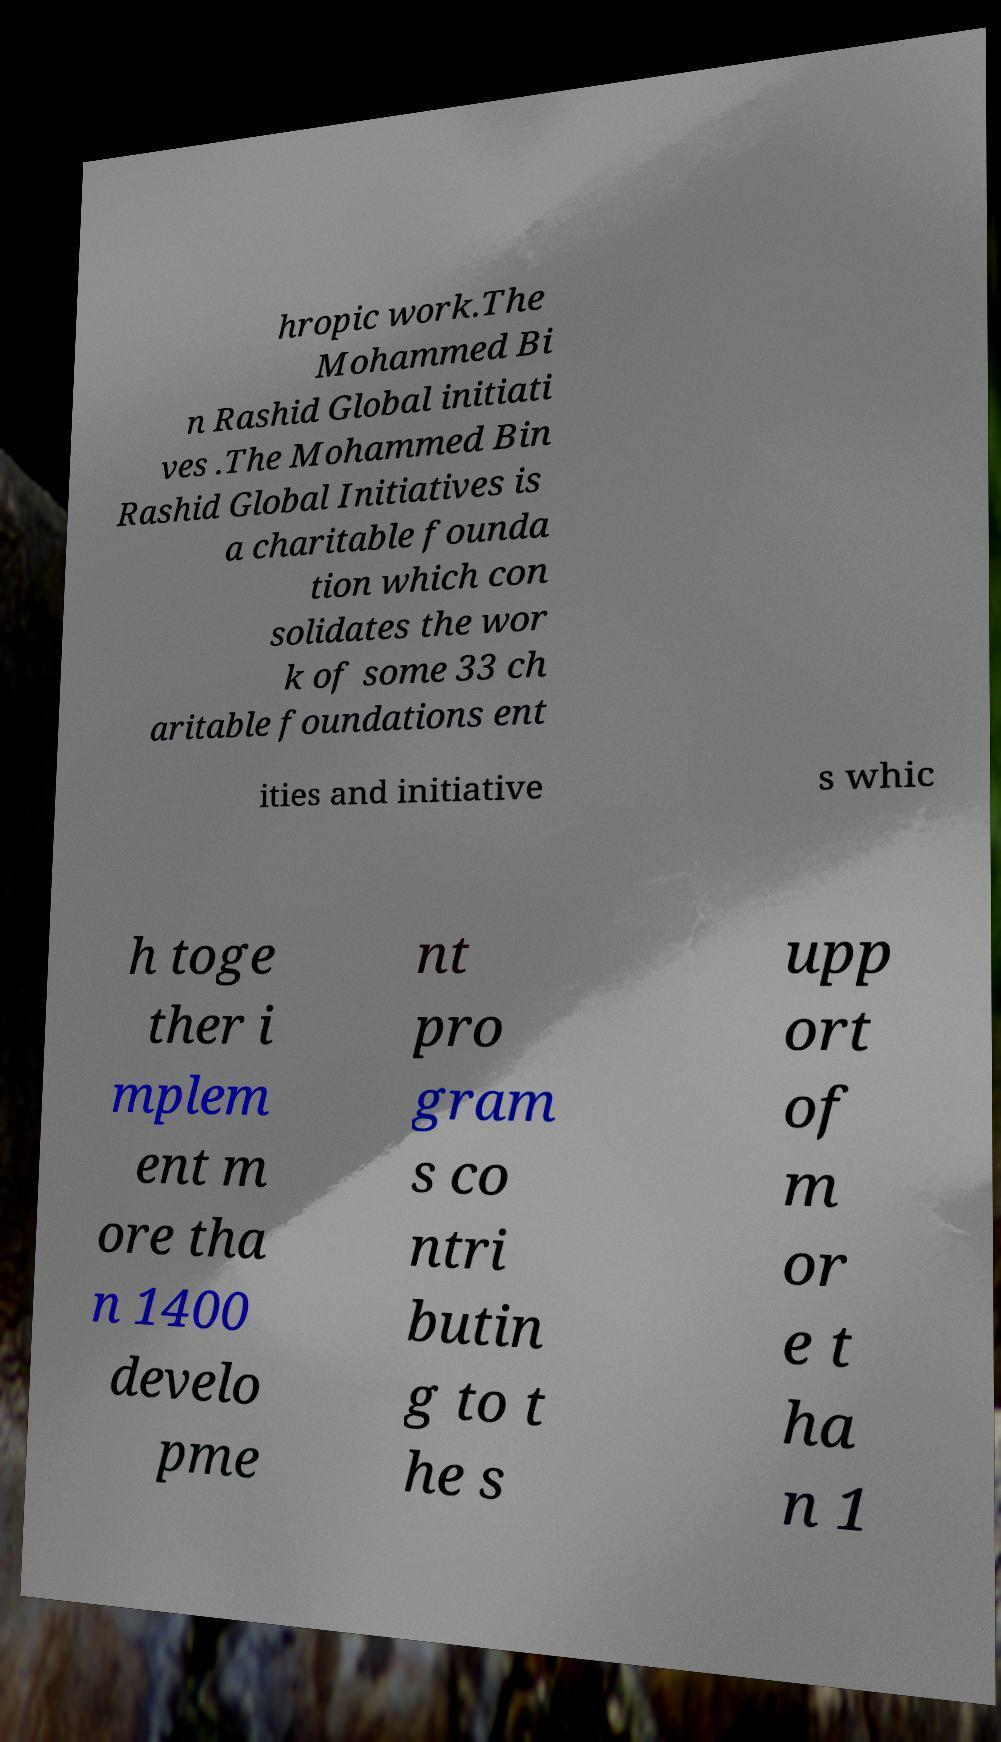Can you accurately transcribe the text from the provided image for me? hropic work.The Mohammed Bi n Rashid Global initiati ves .The Mohammed Bin Rashid Global Initiatives is a charitable founda tion which con solidates the wor k of some 33 ch aritable foundations ent ities and initiative s whic h toge ther i mplem ent m ore tha n 1400 develo pme nt pro gram s co ntri butin g to t he s upp ort of m or e t ha n 1 